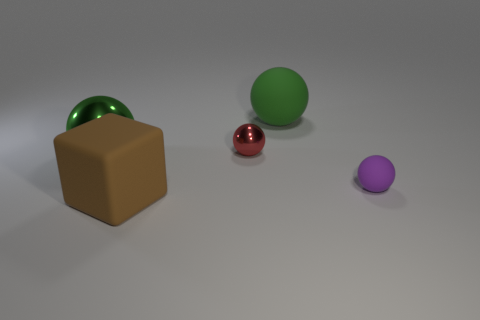What number of small rubber things have the same shape as the tiny shiny thing?
Provide a short and direct response. 1. What is the size of the metal object that is left of the shiny sphere right of the big thing in front of the tiny purple object?
Offer a terse response. Large. Does the green sphere in front of the red shiny sphere have the same material as the large cube?
Give a very brief answer. No. Is the number of large metal balls that are in front of the big metal object the same as the number of large matte spheres right of the small rubber thing?
Your answer should be compact. Yes. There is another tiny object that is the same shape as the purple matte thing; what is it made of?
Provide a short and direct response. Metal. There is a small sphere right of the big matte object that is on the right side of the brown object; are there any big brown matte things in front of it?
Keep it short and to the point. Yes. Do the large green thing that is on the left side of the big matte cube and the matte thing that is in front of the purple rubber object have the same shape?
Ensure brevity in your answer.  No. Is the number of spheres that are in front of the big metal ball greater than the number of small purple cylinders?
Keep it short and to the point. Yes. How many objects are small red shiny objects or tiny cyan cubes?
Your response must be concise. 1. The matte cube is what color?
Keep it short and to the point. Brown. 